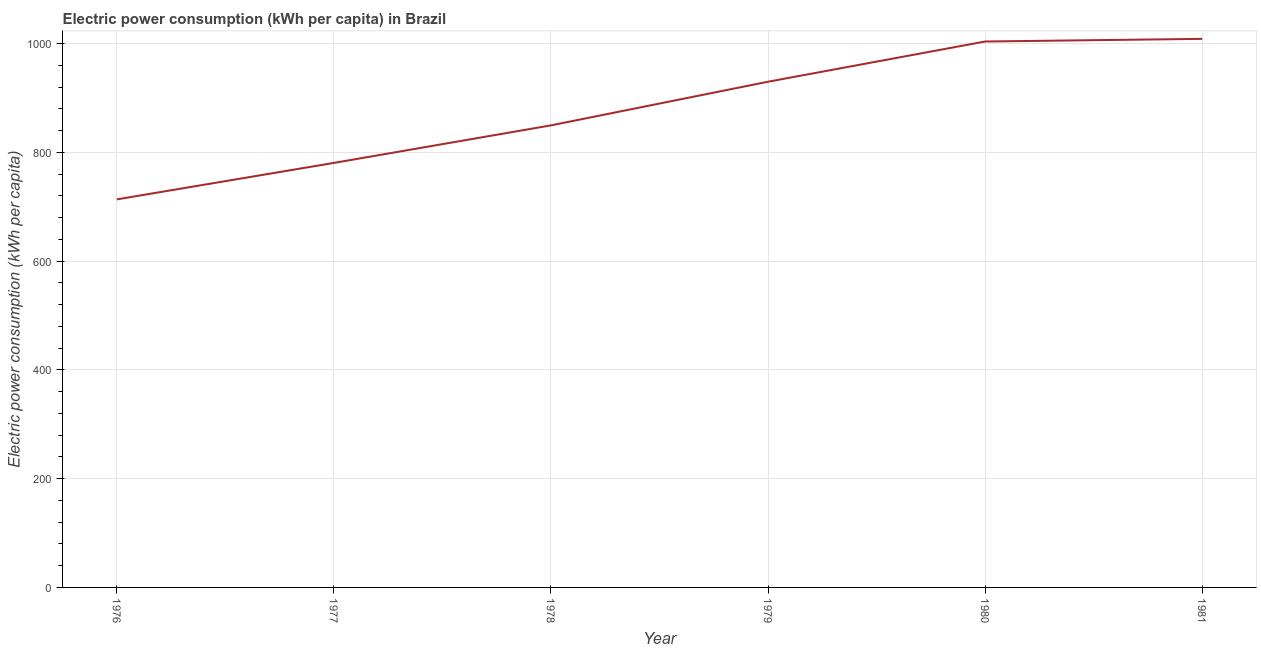What is the electric power consumption in 1981?
Give a very brief answer. 1009. Across all years, what is the maximum electric power consumption?
Make the answer very short. 1009. Across all years, what is the minimum electric power consumption?
Provide a succinct answer. 713.73. In which year was the electric power consumption maximum?
Give a very brief answer. 1981. In which year was the electric power consumption minimum?
Offer a very short reply. 1976. What is the sum of the electric power consumption?
Make the answer very short. 5287.73. What is the difference between the electric power consumption in 1977 and 1978?
Offer a very short reply. -69.05. What is the average electric power consumption per year?
Make the answer very short. 881.29. What is the median electric power consumption?
Provide a short and direct response. 890.02. Do a majority of the years between 1980 and 1976 (inclusive) have electric power consumption greater than 920 kWh per capita?
Your answer should be compact. Yes. What is the ratio of the electric power consumption in 1977 to that in 1978?
Offer a very short reply. 0.92. Is the difference between the electric power consumption in 1977 and 1980 greater than the difference between any two years?
Provide a short and direct response. No. What is the difference between the highest and the second highest electric power consumption?
Make the answer very short. 4.87. Is the sum of the electric power consumption in 1978 and 1980 greater than the maximum electric power consumption across all years?
Provide a succinct answer. Yes. What is the difference between the highest and the lowest electric power consumption?
Your answer should be very brief. 295.27. In how many years, is the electric power consumption greater than the average electric power consumption taken over all years?
Provide a succinct answer. 3. How many lines are there?
Give a very brief answer. 1. How many years are there in the graph?
Offer a very short reply. 6. Does the graph contain grids?
Your answer should be very brief. Yes. What is the title of the graph?
Provide a short and direct response. Electric power consumption (kWh per capita) in Brazil. What is the label or title of the X-axis?
Give a very brief answer. Year. What is the label or title of the Y-axis?
Ensure brevity in your answer.  Electric power consumption (kWh per capita). What is the Electric power consumption (kWh per capita) in 1976?
Your answer should be compact. 713.73. What is the Electric power consumption (kWh per capita) of 1977?
Give a very brief answer. 780.84. What is the Electric power consumption (kWh per capita) in 1978?
Your response must be concise. 849.89. What is the Electric power consumption (kWh per capita) in 1979?
Ensure brevity in your answer.  930.15. What is the Electric power consumption (kWh per capita) in 1980?
Offer a very short reply. 1004.13. What is the Electric power consumption (kWh per capita) in 1981?
Provide a succinct answer. 1009. What is the difference between the Electric power consumption (kWh per capita) in 1976 and 1977?
Your answer should be very brief. -67.11. What is the difference between the Electric power consumption (kWh per capita) in 1976 and 1978?
Give a very brief answer. -136.16. What is the difference between the Electric power consumption (kWh per capita) in 1976 and 1979?
Offer a very short reply. -216.43. What is the difference between the Electric power consumption (kWh per capita) in 1976 and 1980?
Your answer should be very brief. -290.4. What is the difference between the Electric power consumption (kWh per capita) in 1976 and 1981?
Keep it short and to the point. -295.27. What is the difference between the Electric power consumption (kWh per capita) in 1977 and 1978?
Keep it short and to the point. -69.05. What is the difference between the Electric power consumption (kWh per capita) in 1977 and 1979?
Offer a terse response. -149.32. What is the difference between the Electric power consumption (kWh per capita) in 1977 and 1980?
Your answer should be compact. -223.29. What is the difference between the Electric power consumption (kWh per capita) in 1977 and 1981?
Give a very brief answer. -228.16. What is the difference between the Electric power consumption (kWh per capita) in 1978 and 1979?
Your answer should be compact. -80.27. What is the difference between the Electric power consumption (kWh per capita) in 1978 and 1980?
Provide a succinct answer. -154.24. What is the difference between the Electric power consumption (kWh per capita) in 1978 and 1981?
Your response must be concise. -159.11. What is the difference between the Electric power consumption (kWh per capita) in 1979 and 1980?
Your answer should be very brief. -73.97. What is the difference between the Electric power consumption (kWh per capita) in 1979 and 1981?
Your response must be concise. -78.84. What is the difference between the Electric power consumption (kWh per capita) in 1980 and 1981?
Provide a succinct answer. -4.87. What is the ratio of the Electric power consumption (kWh per capita) in 1976 to that in 1977?
Offer a very short reply. 0.91. What is the ratio of the Electric power consumption (kWh per capita) in 1976 to that in 1978?
Ensure brevity in your answer.  0.84. What is the ratio of the Electric power consumption (kWh per capita) in 1976 to that in 1979?
Give a very brief answer. 0.77. What is the ratio of the Electric power consumption (kWh per capita) in 1976 to that in 1980?
Offer a very short reply. 0.71. What is the ratio of the Electric power consumption (kWh per capita) in 1976 to that in 1981?
Provide a short and direct response. 0.71. What is the ratio of the Electric power consumption (kWh per capita) in 1977 to that in 1978?
Your response must be concise. 0.92. What is the ratio of the Electric power consumption (kWh per capita) in 1977 to that in 1979?
Your answer should be very brief. 0.84. What is the ratio of the Electric power consumption (kWh per capita) in 1977 to that in 1980?
Provide a short and direct response. 0.78. What is the ratio of the Electric power consumption (kWh per capita) in 1977 to that in 1981?
Your response must be concise. 0.77. What is the ratio of the Electric power consumption (kWh per capita) in 1978 to that in 1979?
Make the answer very short. 0.91. What is the ratio of the Electric power consumption (kWh per capita) in 1978 to that in 1980?
Ensure brevity in your answer.  0.85. What is the ratio of the Electric power consumption (kWh per capita) in 1978 to that in 1981?
Your answer should be compact. 0.84. What is the ratio of the Electric power consumption (kWh per capita) in 1979 to that in 1980?
Your answer should be compact. 0.93. What is the ratio of the Electric power consumption (kWh per capita) in 1979 to that in 1981?
Make the answer very short. 0.92. 